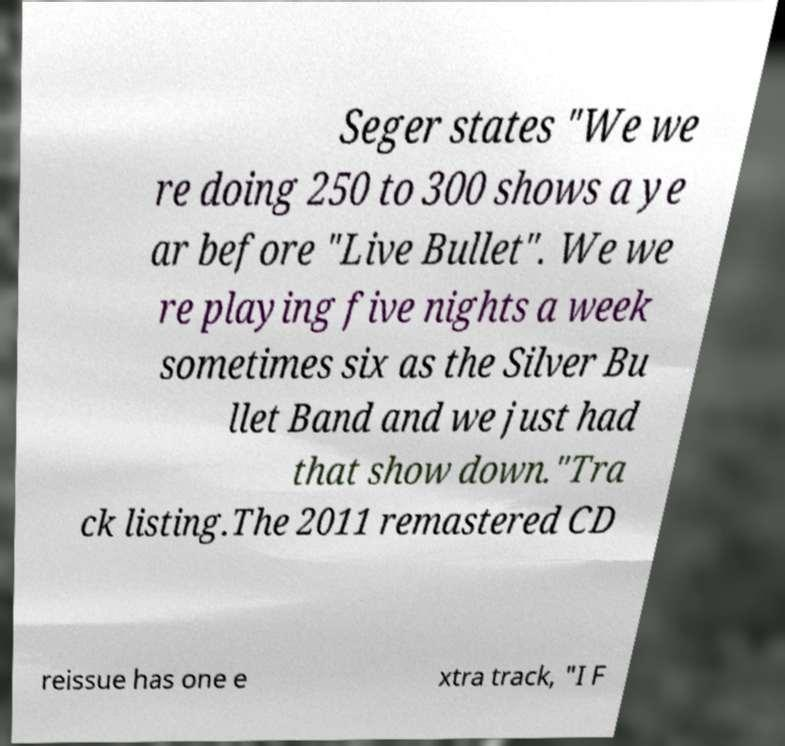What messages or text are displayed in this image? I need them in a readable, typed format. Seger states "We we re doing 250 to 300 shows a ye ar before "Live Bullet". We we re playing five nights a week sometimes six as the Silver Bu llet Band and we just had that show down."Tra ck listing.The 2011 remastered CD reissue has one e xtra track, "I F 